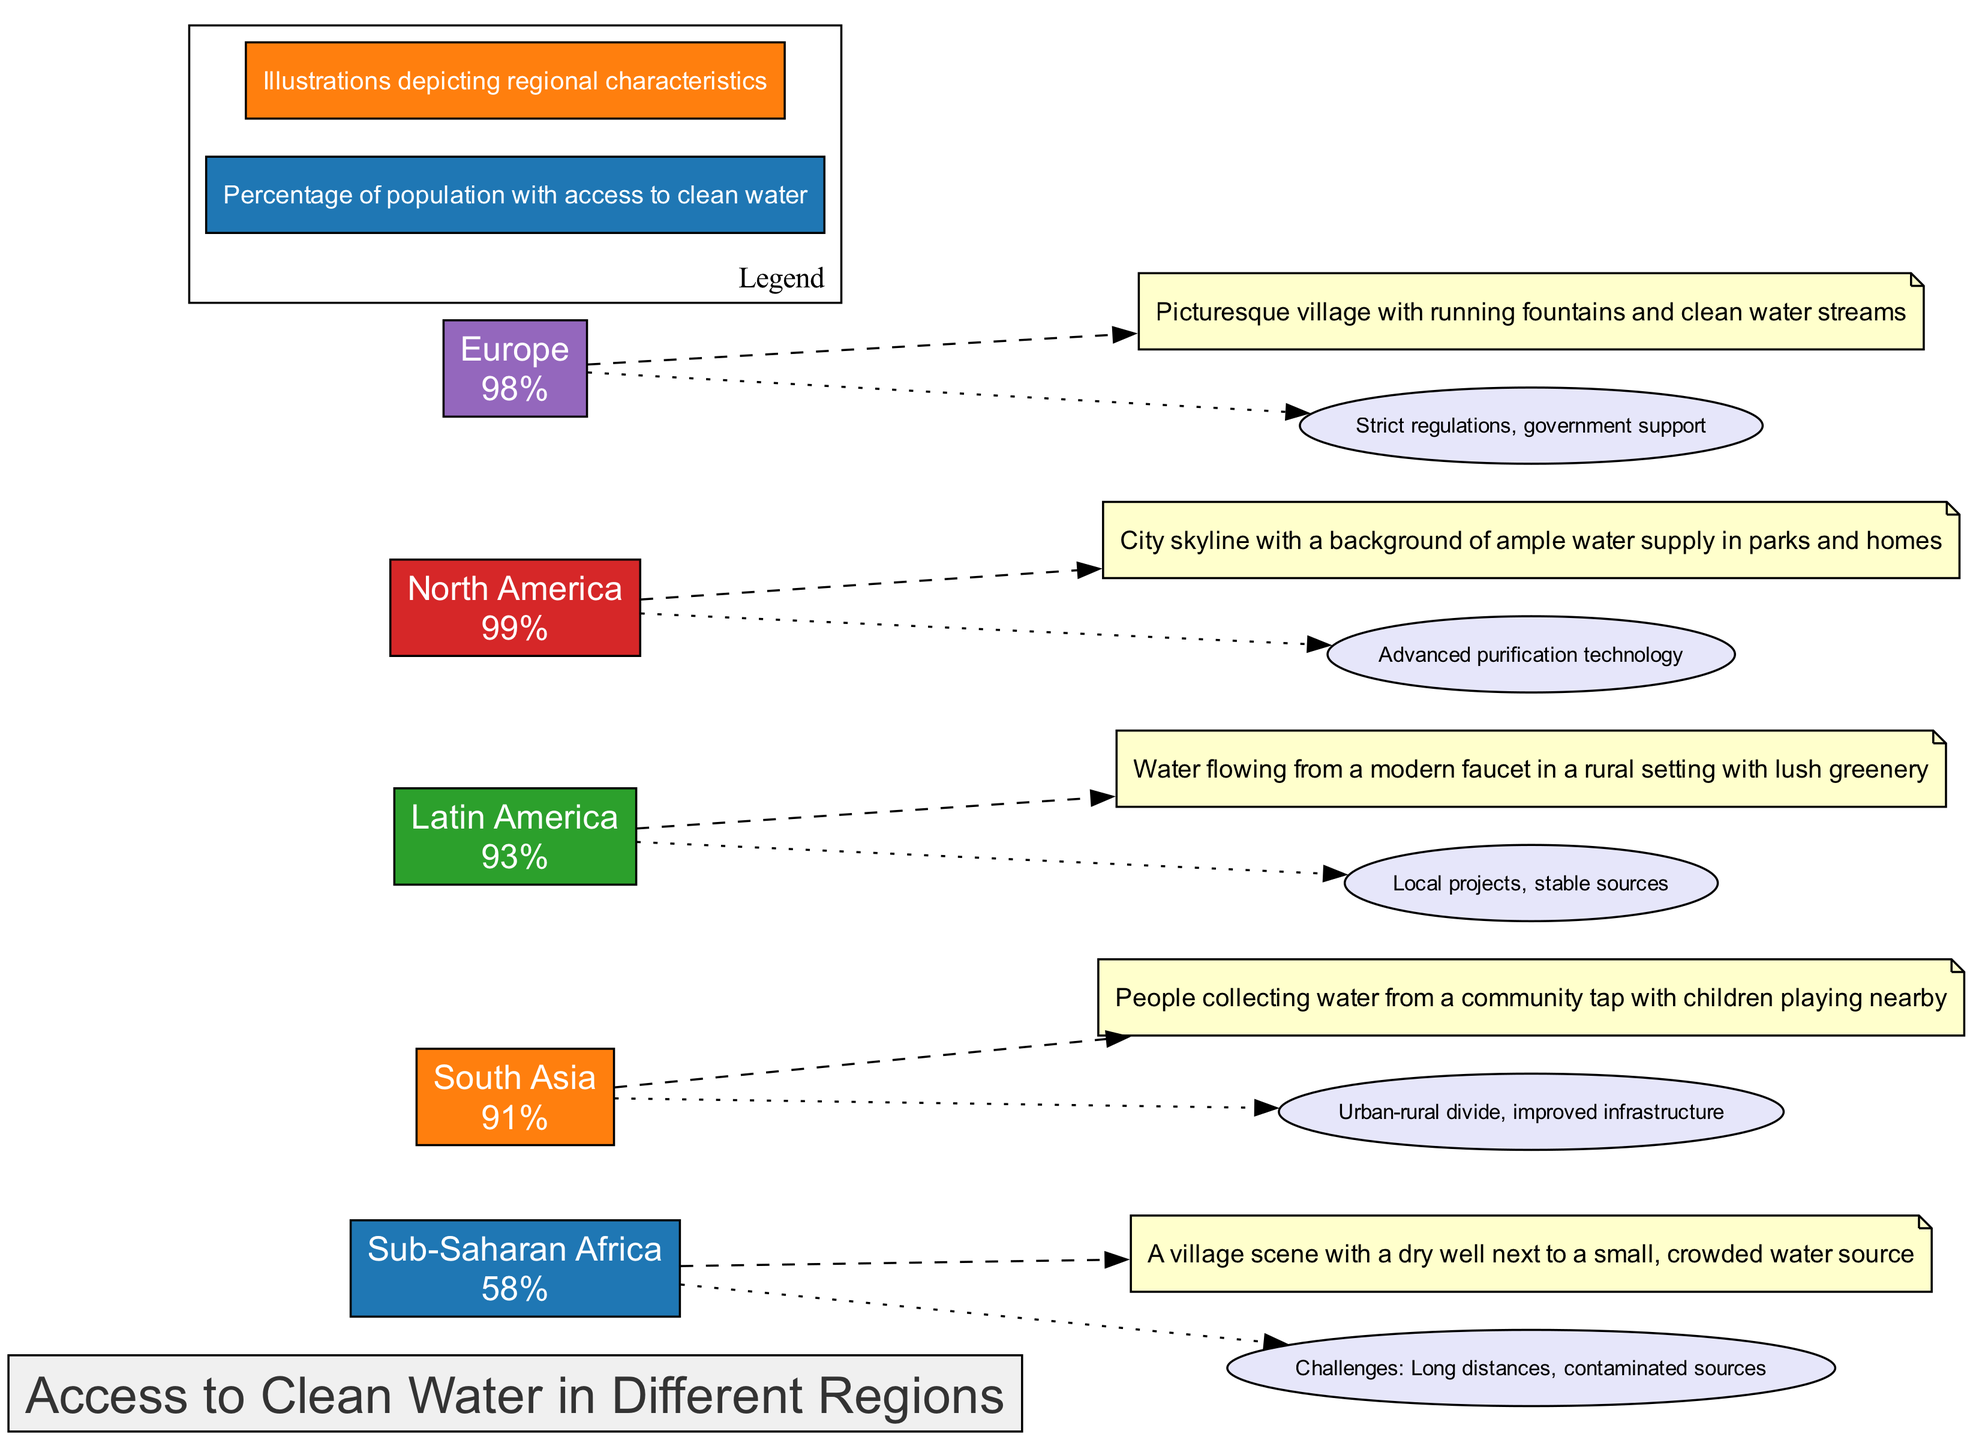What is the percentage access to clean water in Sub-Saharan Africa? The diagram indicates that the percentage access for Sub-Saharan Africa is clearly displayed next to the region's name. It shows a value of 58%.
Answer: 58% What illustration is shown for North America? The illustration for North America depicts a city skyline with ample water supply in parks and homes, which can be found next to the region's bar.
Answer: City skyline with ample water supply in parks and homes Which region has the highest percentage of access to clean water? By comparing the access percentages listed for each region, we can see that North America has the highest access at 99%.
Answer: North America What annotation is associated with Sub-Saharan Africa? The diagram includes annotations that are connected to the Sub-Saharan Africa region node. This specific region has a note stating the challenges faced: "Long distances, contaminated sources."
Answer: Challenges: Long distances, contaminated sources How many regions are represented in the diagram? The diagram includes a specific bar for each region listed. There are a total of five regions represented: Sub-Saharan Africa, South Asia, Latin America, North America, and Europe.
Answer: 5 What factors contribute to the access to clean water in Europe? The diagram details annotations for Europe, stating "Strict regulations, government support." These factors are believed to facilitate high access to clean water in this region.
Answer: Strict regulations, government support Which region has access to clean water slightly lower than Latin America? The comparison shows that South Asia has a percentage of 91%, which is slightly lower than Latin America's 93%.
Answer: South Asia What color represents Latin America in the diagram? Each region's bar is designated a specific color, and Latin America's bar is represented in green, specifically the color code #2ca02c.
Answer: #2ca02c What is the primary challenge for South Asia regarding clean water access? The diagram notes that South Asia faces an "Urban-rural divide, improved infrastructure" challenge, indicating a disparity in access between urban and rural areas.
Answer: Urban-rural divide, improved infrastructure 